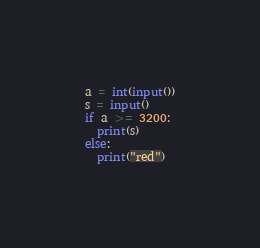Convert code to text. <code><loc_0><loc_0><loc_500><loc_500><_Python_>a = int(input())
s = input()
if a >= 3200:
  print(s)
else:
  print("red")</code> 